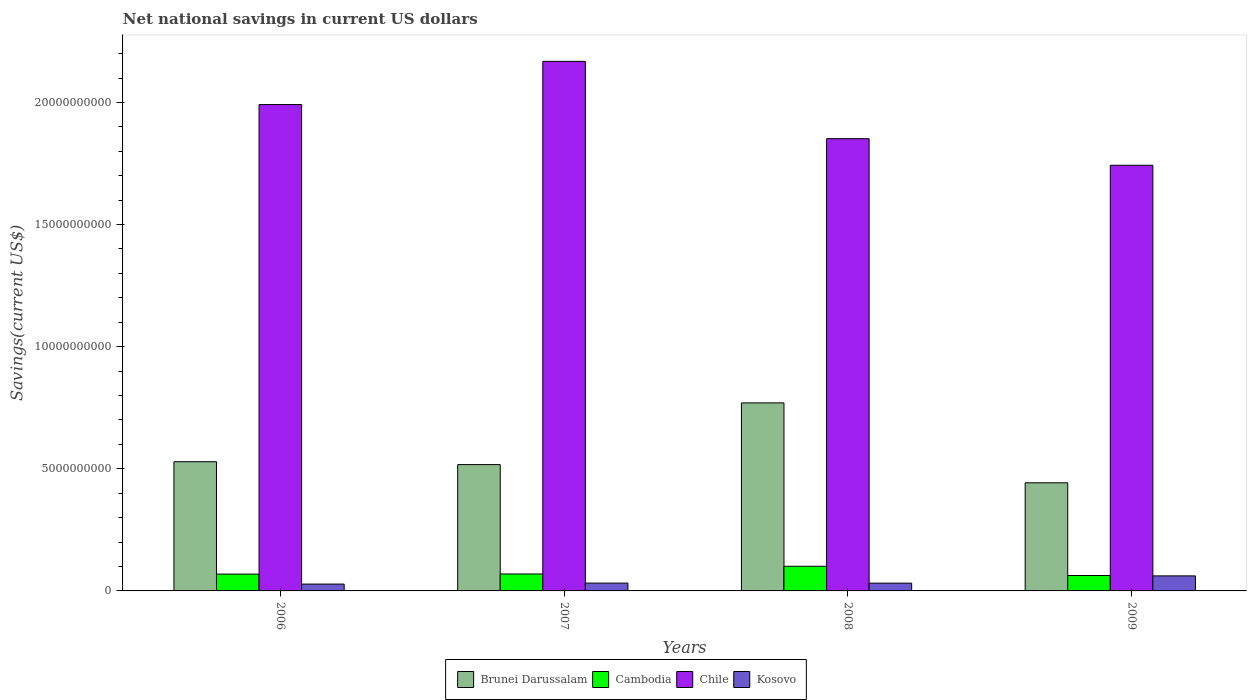How many different coloured bars are there?
Provide a succinct answer. 4. What is the label of the 1st group of bars from the left?
Your response must be concise. 2006. In how many cases, is the number of bars for a given year not equal to the number of legend labels?
Your answer should be compact. 0. What is the net national savings in Cambodia in 2006?
Make the answer very short. 6.89e+08. Across all years, what is the maximum net national savings in Chile?
Provide a short and direct response. 2.17e+1. Across all years, what is the minimum net national savings in Kosovo?
Make the answer very short. 2.80e+08. In which year was the net national savings in Brunei Darussalam maximum?
Provide a short and direct response. 2008. In which year was the net national savings in Cambodia minimum?
Provide a succinct answer. 2009. What is the total net national savings in Brunei Darussalam in the graph?
Your response must be concise. 2.26e+1. What is the difference between the net national savings in Kosovo in 2006 and that in 2008?
Your answer should be compact. -3.82e+07. What is the difference between the net national savings in Chile in 2008 and the net national savings in Cambodia in 2007?
Your answer should be very brief. 1.78e+1. What is the average net national savings in Kosovo per year?
Keep it short and to the point. 3.84e+08. In the year 2008, what is the difference between the net national savings in Cambodia and net national savings in Kosovo?
Provide a short and direct response. 6.91e+08. What is the ratio of the net national savings in Cambodia in 2006 to that in 2007?
Keep it short and to the point. 0.99. What is the difference between the highest and the second highest net national savings in Brunei Darussalam?
Give a very brief answer. 2.41e+09. What is the difference between the highest and the lowest net national savings in Cambodia?
Your response must be concise. 3.78e+08. Is the sum of the net national savings in Brunei Darussalam in 2007 and 2008 greater than the maximum net national savings in Cambodia across all years?
Your response must be concise. Yes. How many bars are there?
Offer a very short reply. 16. Does the graph contain any zero values?
Give a very brief answer. No. Does the graph contain grids?
Make the answer very short. No. Where does the legend appear in the graph?
Your answer should be compact. Bottom center. How many legend labels are there?
Your answer should be very brief. 4. How are the legend labels stacked?
Offer a very short reply. Horizontal. What is the title of the graph?
Your answer should be compact. Net national savings in current US dollars. What is the label or title of the Y-axis?
Provide a succinct answer. Savings(current US$). What is the Savings(current US$) in Brunei Darussalam in 2006?
Your answer should be compact. 5.29e+09. What is the Savings(current US$) of Cambodia in 2006?
Provide a succinct answer. 6.89e+08. What is the Savings(current US$) in Chile in 2006?
Keep it short and to the point. 1.99e+1. What is the Savings(current US$) of Kosovo in 2006?
Offer a terse response. 2.80e+08. What is the Savings(current US$) in Brunei Darussalam in 2007?
Your response must be concise. 5.17e+09. What is the Savings(current US$) in Cambodia in 2007?
Make the answer very short. 6.94e+08. What is the Savings(current US$) in Chile in 2007?
Provide a short and direct response. 2.17e+1. What is the Savings(current US$) of Kosovo in 2007?
Ensure brevity in your answer.  3.20e+08. What is the Savings(current US$) in Brunei Darussalam in 2008?
Your answer should be very brief. 7.70e+09. What is the Savings(current US$) in Cambodia in 2008?
Your answer should be very brief. 1.01e+09. What is the Savings(current US$) of Chile in 2008?
Make the answer very short. 1.85e+1. What is the Savings(current US$) in Kosovo in 2008?
Make the answer very short. 3.18e+08. What is the Savings(current US$) in Brunei Darussalam in 2009?
Offer a very short reply. 4.43e+09. What is the Savings(current US$) of Cambodia in 2009?
Give a very brief answer. 6.31e+08. What is the Savings(current US$) in Chile in 2009?
Keep it short and to the point. 1.74e+1. What is the Savings(current US$) of Kosovo in 2009?
Offer a very short reply. 6.16e+08. Across all years, what is the maximum Savings(current US$) in Brunei Darussalam?
Make the answer very short. 7.70e+09. Across all years, what is the maximum Savings(current US$) in Cambodia?
Your response must be concise. 1.01e+09. Across all years, what is the maximum Savings(current US$) in Chile?
Ensure brevity in your answer.  2.17e+1. Across all years, what is the maximum Savings(current US$) in Kosovo?
Ensure brevity in your answer.  6.16e+08. Across all years, what is the minimum Savings(current US$) of Brunei Darussalam?
Give a very brief answer. 4.43e+09. Across all years, what is the minimum Savings(current US$) in Cambodia?
Provide a short and direct response. 6.31e+08. Across all years, what is the minimum Savings(current US$) of Chile?
Ensure brevity in your answer.  1.74e+1. Across all years, what is the minimum Savings(current US$) in Kosovo?
Ensure brevity in your answer.  2.80e+08. What is the total Savings(current US$) of Brunei Darussalam in the graph?
Make the answer very short. 2.26e+1. What is the total Savings(current US$) of Cambodia in the graph?
Offer a very short reply. 3.02e+09. What is the total Savings(current US$) of Chile in the graph?
Your response must be concise. 7.75e+1. What is the total Savings(current US$) of Kosovo in the graph?
Ensure brevity in your answer.  1.53e+09. What is the difference between the Savings(current US$) of Brunei Darussalam in 2006 and that in 2007?
Ensure brevity in your answer.  1.18e+08. What is the difference between the Savings(current US$) in Cambodia in 2006 and that in 2007?
Make the answer very short. -5.39e+06. What is the difference between the Savings(current US$) in Chile in 2006 and that in 2007?
Offer a very short reply. -1.77e+09. What is the difference between the Savings(current US$) of Kosovo in 2006 and that in 2007?
Offer a terse response. -4.01e+07. What is the difference between the Savings(current US$) in Brunei Darussalam in 2006 and that in 2008?
Make the answer very short. -2.41e+09. What is the difference between the Savings(current US$) of Cambodia in 2006 and that in 2008?
Keep it short and to the point. -3.21e+08. What is the difference between the Savings(current US$) of Chile in 2006 and that in 2008?
Make the answer very short. 1.40e+09. What is the difference between the Savings(current US$) in Kosovo in 2006 and that in 2008?
Give a very brief answer. -3.82e+07. What is the difference between the Savings(current US$) of Brunei Darussalam in 2006 and that in 2009?
Your response must be concise. 8.63e+08. What is the difference between the Savings(current US$) in Cambodia in 2006 and that in 2009?
Offer a very short reply. 5.73e+07. What is the difference between the Savings(current US$) in Chile in 2006 and that in 2009?
Your response must be concise. 2.49e+09. What is the difference between the Savings(current US$) of Kosovo in 2006 and that in 2009?
Keep it short and to the point. -3.36e+08. What is the difference between the Savings(current US$) of Brunei Darussalam in 2007 and that in 2008?
Offer a terse response. -2.53e+09. What is the difference between the Savings(current US$) in Cambodia in 2007 and that in 2008?
Keep it short and to the point. -3.15e+08. What is the difference between the Savings(current US$) in Chile in 2007 and that in 2008?
Your answer should be very brief. 3.17e+09. What is the difference between the Savings(current US$) of Kosovo in 2007 and that in 2008?
Provide a succinct answer. 1.89e+06. What is the difference between the Savings(current US$) in Brunei Darussalam in 2007 and that in 2009?
Your response must be concise. 7.45e+08. What is the difference between the Savings(current US$) in Cambodia in 2007 and that in 2009?
Provide a short and direct response. 6.27e+07. What is the difference between the Savings(current US$) in Chile in 2007 and that in 2009?
Ensure brevity in your answer.  4.25e+09. What is the difference between the Savings(current US$) in Kosovo in 2007 and that in 2009?
Offer a very short reply. -2.96e+08. What is the difference between the Savings(current US$) in Brunei Darussalam in 2008 and that in 2009?
Ensure brevity in your answer.  3.27e+09. What is the difference between the Savings(current US$) of Cambodia in 2008 and that in 2009?
Keep it short and to the point. 3.78e+08. What is the difference between the Savings(current US$) in Chile in 2008 and that in 2009?
Offer a very short reply. 1.09e+09. What is the difference between the Savings(current US$) of Kosovo in 2008 and that in 2009?
Give a very brief answer. -2.98e+08. What is the difference between the Savings(current US$) of Brunei Darussalam in 2006 and the Savings(current US$) of Cambodia in 2007?
Your answer should be compact. 4.60e+09. What is the difference between the Savings(current US$) of Brunei Darussalam in 2006 and the Savings(current US$) of Chile in 2007?
Offer a terse response. -1.64e+1. What is the difference between the Savings(current US$) in Brunei Darussalam in 2006 and the Savings(current US$) in Kosovo in 2007?
Ensure brevity in your answer.  4.97e+09. What is the difference between the Savings(current US$) in Cambodia in 2006 and the Savings(current US$) in Chile in 2007?
Your answer should be compact. -2.10e+1. What is the difference between the Savings(current US$) of Cambodia in 2006 and the Savings(current US$) of Kosovo in 2007?
Make the answer very short. 3.69e+08. What is the difference between the Savings(current US$) in Chile in 2006 and the Savings(current US$) in Kosovo in 2007?
Provide a short and direct response. 1.96e+1. What is the difference between the Savings(current US$) in Brunei Darussalam in 2006 and the Savings(current US$) in Cambodia in 2008?
Your answer should be compact. 4.28e+09. What is the difference between the Savings(current US$) of Brunei Darussalam in 2006 and the Savings(current US$) of Chile in 2008?
Keep it short and to the point. -1.32e+1. What is the difference between the Savings(current US$) in Brunei Darussalam in 2006 and the Savings(current US$) in Kosovo in 2008?
Provide a short and direct response. 4.97e+09. What is the difference between the Savings(current US$) of Cambodia in 2006 and the Savings(current US$) of Chile in 2008?
Your answer should be very brief. -1.78e+1. What is the difference between the Savings(current US$) in Cambodia in 2006 and the Savings(current US$) in Kosovo in 2008?
Your answer should be very brief. 3.70e+08. What is the difference between the Savings(current US$) of Chile in 2006 and the Savings(current US$) of Kosovo in 2008?
Your answer should be very brief. 1.96e+1. What is the difference between the Savings(current US$) in Brunei Darussalam in 2006 and the Savings(current US$) in Cambodia in 2009?
Ensure brevity in your answer.  4.66e+09. What is the difference between the Savings(current US$) in Brunei Darussalam in 2006 and the Savings(current US$) in Chile in 2009?
Give a very brief answer. -1.21e+1. What is the difference between the Savings(current US$) in Brunei Darussalam in 2006 and the Savings(current US$) in Kosovo in 2009?
Ensure brevity in your answer.  4.67e+09. What is the difference between the Savings(current US$) of Cambodia in 2006 and the Savings(current US$) of Chile in 2009?
Make the answer very short. -1.67e+1. What is the difference between the Savings(current US$) of Cambodia in 2006 and the Savings(current US$) of Kosovo in 2009?
Your answer should be compact. 7.27e+07. What is the difference between the Savings(current US$) of Chile in 2006 and the Savings(current US$) of Kosovo in 2009?
Give a very brief answer. 1.93e+1. What is the difference between the Savings(current US$) of Brunei Darussalam in 2007 and the Savings(current US$) of Cambodia in 2008?
Your answer should be compact. 4.16e+09. What is the difference between the Savings(current US$) in Brunei Darussalam in 2007 and the Savings(current US$) in Chile in 2008?
Provide a short and direct response. -1.33e+1. What is the difference between the Savings(current US$) in Brunei Darussalam in 2007 and the Savings(current US$) in Kosovo in 2008?
Offer a very short reply. 4.85e+09. What is the difference between the Savings(current US$) of Cambodia in 2007 and the Savings(current US$) of Chile in 2008?
Offer a very short reply. -1.78e+1. What is the difference between the Savings(current US$) of Cambodia in 2007 and the Savings(current US$) of Kosovo in 2008?
Offer a very short reply. 3.76e+08. What is the difference between the Savings(current US$) in Chile in 2007 and the Savings(current US$) in Kosovo in 2008?
Give a very brief answer. 2.14e+1. What is the difference between the Savings(current US$) of Brunei Darussalam in 2007 and the Savings(current US$) of Cambodia in 2009?
Ensure brevity in your answer.  4.54e+09. What is the difference between the Savings(current US$) of Brunei Darussalam in 2007 and the Savings(current US$) of Chile in 2009?
Provide a short and direct response. -1.23e+1. What is the difference between the Savings(current US$) of Brunei Darussalam in 2007 and the Savings(current US$) of Kosovo in 2009?
Ensure brevity in your answer.  4.56e+09. What is the difference between the Savings(current US$) in Cambodia in 2007 and the Savings(current US$) in Chile in 2009?
Offer a terse response. -1.67e+1. What is the difference between the Savings(current US$) in Cambodia in 2007 and the Savings(current US$) in Kosovo in 2009?
Keep it short and to the point. 7.81e+07. What is the difference between the Savings(current US$) of Chile in 2007 and the Savings(current US$) of Kosovo in 2009?
Provide a succinct answer. 2.11e+1. What is the difference between the Savings(current US$) in Brunei Darussalam in 2008 and the Savings(current US$) in Cambodia in 2009?
Ensure brevity in your answer.  7.07e+09. What is the difference between the Savings(current US$) in Brunei Darussalam in 2008 and the Savings(current US$) in Chile in 2009?
Provide a succinct answer. -9.73e+09. What is the difference between the Savings(current US$) in Brunei Darussalam in 2008 and the Savings(current US$) in Kosovo in 2009?
Provide a short and direct response. 7.08e+09. What is the difference between the Savings(current US$) in Cambodia in 2008 and the Savings(current US$) in Chile in 2009?
Your response must be concise. -1.64e+1. What is the difference between the Savings(current US$) of Cambodia in 2008 and the Savings(current US$) of Kosovo in 2009?
Give a very brief answer. 3.93e+08. What is the difference between the Savings(current US$) in Chile in 2008 and the Savings(current US$) in Kosovo in 2009?
Make the answer very short. 1.79e+1. What is the average Savings(current US$) of Brunei Darussalam per year?
Ensure brevity in your answer.  5.65e+09. What is the average Savings(current US$) of Cambodia per year?
Offer a terse response. 7.56e+08. What is the average Savings(current US$) in Chile per year?
Provide a short and direct response. 1.94e+1. What is the average Savings(current US$) of Kosovo per year?
Ensure brevity in your answer.  3.84e+08. In the year 2006, what is the difference between the Savings(current US$) of Brunei Darussalam and Savings(current US$) of Cambodia?
Provide a succinct answer. 4.60e+09. In the year 2006, what is the difference between the Savings(current US$) in Brunei Darussalam and Savings(current US$) in Chile?
Your response must be concise. -1.46e+1. In the year 2006, what is the difference between the Savings(current US$) of Brunei Darussalam and Savings(current US$) of Kosovo?
Your answer should be compact. 5.01e+09. In the year 2006, what is the difference between the Savings(current US$) in Cambodia and Savings(current US$) in Chile?
Give a very brief answer. -1.92e+1. In the year 2006, what is the difference between the Savings(current US$) in Cambodia and Savings(current US$) in Kosovo?
Your answer should be very brief. 4.09e+08. In the year 2006, what is the difference between the Savings(current US$) in Chile and Savings(current US$) in Kosovo?
Your response must be concise. 1.96e+1. In the year 2007, what is the difference between the Savings(current US$) in Brunei Darussalam and Savings(current US$) in Cambodia?
Offer a terse response. 4.48e+09. In the year 2007, what is the difference between the Savings(current US$) of Brunei Darussalam and Savings(current US$) of Chile?
Provide a short and direct response. -1.65e+1. In the year 2007, what is the difference between the Savings(current US$) of Brunei Darussalam and Savings(current US$) of Kosovo?
Ensure brevity in your answer.  4.85e+09. In the year 2007, what is the difference between the Savings(current US$) of Cambodia and Savings(current US$) of Chile?
Your answer should be compact. -2.10e+1. In the year 2007, what is the difference between the Savings(current US$) of Cambodia and Savings(current US$) of Kosovo?
Offer a terse response. 3.74e+08. In the year 2007, what is the difference between the Savings(current US$) in Chile and Savings(current US$) in Kosovo?
Keep it short and to the point. 2.14e+1. In the year 2008, what is the difference between the Savings(current US$) in Brunei Darussalam and Savings(current US$) in Cambodia?
Your answer should be compact. 6.69e+09. In the year 2008, what is the difference between the Savings(current US$) of Brunei Darussalam and Savings(current US$) of Chile?
Your response must be concise. -1.08e+1. In the year 2008, what is the difference between the Savings(current US$) in Brunei Darussalam and Savings(current US$) in Kosovo?
Ensure brevity in your answer.  7.38e+09. In the year 2008, what is the difference between the Savings(current US$) in Cambodia and Savings(current US$) in Chile?
Provide a succinct answer. -1.75e+1. In the year 2008, what is the difference between the Savings(current US$) of Cambodia and Savings(current US$) of Kosovo?
Provide a short and direct response. 6.91e+08. In the year 2008, what is the difference between the Savings(current US$) of Chile and Savings(current US$) of Kosovo?
Keep it short and to the point. 1.82e+1. In the year 2009, what is the difference between the Savings(current US$) in Brunei Darussalam and Savings(current US$) in Cambodia?
Keep it short and to the point. 3.80e+09. In the year 2009, what is the difference between the Savings(current US$) of Brunei Darussalam and Savings(current US$) of Chile?
Provide a succinct answer. -1.30e+1. In the year 2009, what is the difference between the Savings(current US$) of Brunei Darussalam and Savings(current US$) of Kosovo?
Give a very brief answer. 3.81e+09. In the year 2009, what is the difference between the Savings(current US$) of Cambodia and Savings(current US$) of Chile?
Offer a very short reply. -1.68e+1. In the year 2009, what is the difference between the Savings(current US$) in Cambodia and Savings(current US$) in Kosovo?
Your answer should be compact. 1.54e+07. In the year 2009, what is the difference between the Savings(current US$) of Chile and Savings(current US$) of Kosovo?
Your answer should be compact. 1.68e+1. What is the ratio of the Savings(current US$) in Brunei Darussalam in 2006 to that in 2007?
Provide a short and direct response. 1.02. What is the ratio of the Savings(current US$) in Chile in 2006 to that in 2007?
Your response must be concise. 0.92. What is the ratio of the Savings(current US$) of Kosovo in 2006 to that in 2007?
Offer a very short reply. 0.87. What is the ratio of the Savings(current US$) of Brunei Darussalam in 2006 to that in 2008?
Give a very brief answer. 0.69. What is the ratio of the Savings(current US$) in Cambodia in 2006 to that in 2008?
Ensure brevity in your answer.  0.68. What is the ratio of the Savings(current US$) of Chile in 2006 to that in 2008?
Ensure brevity in your answer.  1.08. What is the ratio of the Savings(current US$) of Kosovo in 2006 to that in 2008?
Give a very brief answer. 0.88. What is the ratio of the Savings(current US$) of Brunei Darussalam in 2006 to that in 2009?
Provide a short and direct response. 1.2. What is the ratio of the Savings(current US$) of Cambodia in 2006 to that in 2009?
Offer a very short reply. 1.09. What is the ratio of the Savings(current US$) of Chile in 2006 to that in 2009?
Offer a terse response. 1.14. What is the ratio of the Savings(current US$) of Kosovo in 2006 to that in 2009?
Your answer should be very brief. 0.45. What is the ratio of the Savings(current US$) of Brunei Darussalam in 2007 to that in 2008?
Keep it short and to the point. 0.67. What is the ratio of the Savings(current US$) of Cambodia in 2007 to that in 2008?
Keep it short and to the point. 0.69. What is the ratio of the Savings(current US$) of Chile in 2007 to that in 2008?
Give a very brief answer. 1.17. What is the ratio of the Savings(current US$) in Kosovo in 2007 to that in 2008?
Give a very brief answer. 1.01. What is the ratio of the Savings(current US$) in Brunei Darussalam in 2007 to that in 2009?
Keep it short and to the point. 1.17. What is the ratio of the Savings(current US$) of Cambodia in 2007 to that in 2009?
Ensure brevity in your answer.  1.1. What is the ratio of the Savings(current US$) of Chile in 2007 to that in 2009?
Keep it short and to the point. 1.24. What is the ratio of the Savings(current US$) in Kosovo in 2007 to that in 2009?
Your answer should be compact. 0.52. What is the ratio of the Savings(current US$) in Brunei Darussalam in 2008 to that in 2009?
Ensure brevity in your answer.  1.74. What is the ratio of the Savings(current US$) of Cambodia in 2008 to that in 2009?
Offer a very short reply. 1.6. What is the ratio of the Savings(current US$) in Chile in 2008 to that in 2009?
Your response must be concise. 1.06. What is the ratio of the Savings(current US$) in Kosovo in 2008 to that in 2009?
Give a very brief answer. 0.52. What is the difference between the highest and the second highest Savings(current US$) in Brunei Darussalam?
Your response must be concise. 2.41e+09. What is the difference between the highest and the second highest Savings(current US$) of Cambodia?
Give a very brief answer. 3.15e+08. What is the difference between the highest and the second highest Savings(current US$) of Chile?
Your answer should be very brief. 1.77e+09. What is the difference between the highest and the second highest Savings(current US$) of Kosovo?
Offer a terse response. 2.96e+08. What is the difference between the highest and the lowest Savings(current US$) of Brunei Darussalam?
Make the answer very short. 3.27e+09. What is the difference between the highest and the lowest Savings(current US$) of Cambodia?
Make the answer very short. 3.78e+08. What is the difference between the highest and the lowest Savings(current US$) in Chile?
Give a very brief answer. 4.25e+09. What is the difference between the highest and the lowest Savings(current US$) of Kosovo?
Provide a short and direct response. 3.36e+08. 